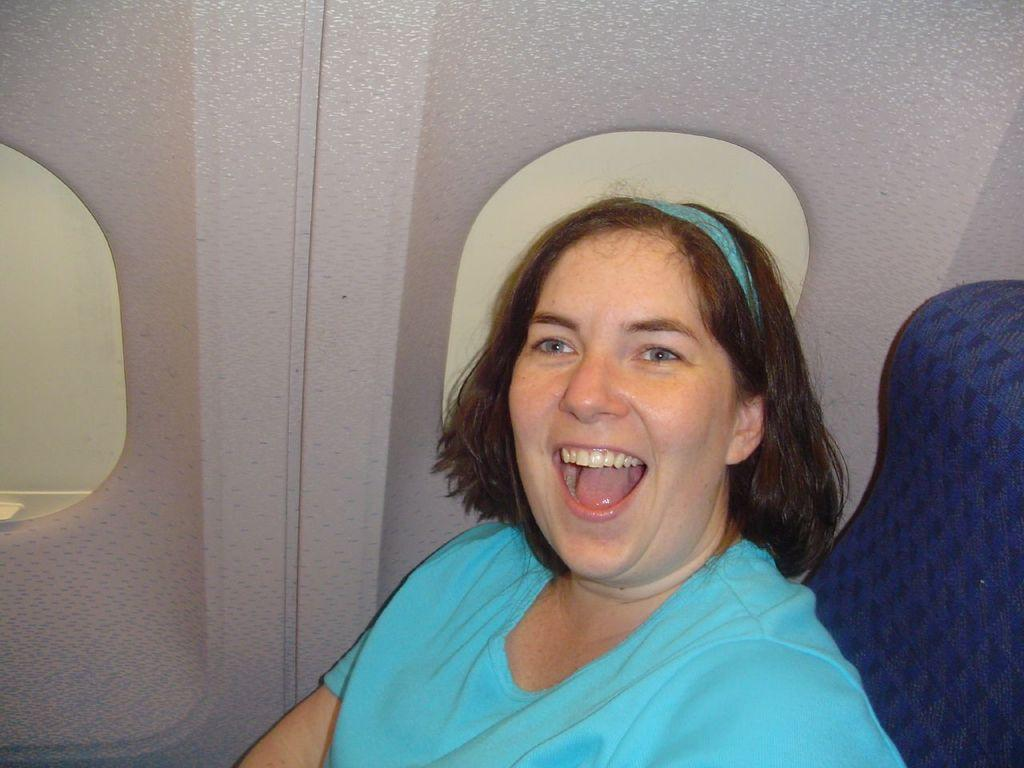Who is present in the image? There is a woman in the image. What is the woman wearing? The woman is wearing a blue t-shirt. What is the woman sitting on? The woman is sitting on a violet color seat. What is the woman's facial expression? The woman is smiling. What can be seen through the glass windows in the image? The details of what can be seen through the glass windows are not provided in the facts. What is the development of the mass in the image? There is no mention of development or mass in the image, as it features a woman sitting on a seat and wearing a blue t-shirt. 